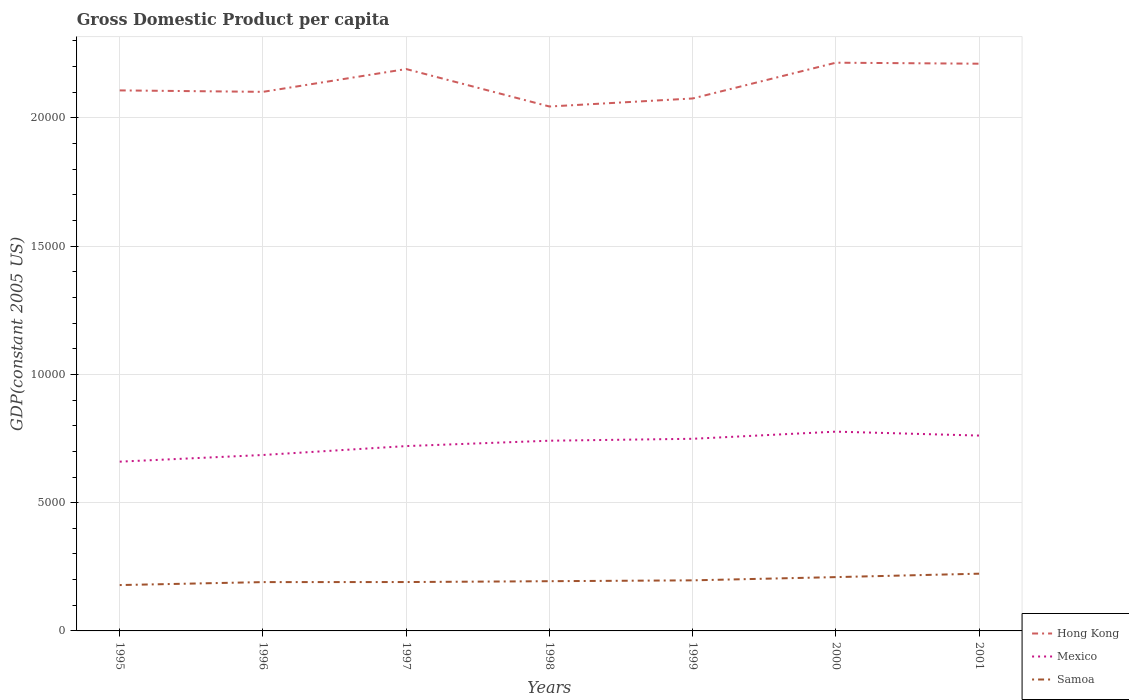Does the line corresponding to Hong Kong intersect with the line corresponding to Samoa?
Your response must be concise. No. Is the number of lines equal to the number of legend labels?
Provide a succinct answer. Yes. Across all years, what is the maximum GDP per capita in Samoa?
Keep it short and to the point. 1787.53. What is the total GDP per capita in Hong Kong in the graph?
Ensure brevity in your answer.  -208.59. What is the difference between the highest and the second highest GDP per capita in Samoa?
Keep it short and to the point. 443.83. What is the difference between the highest and the lowest GDP per capita in Mexico?
Keep it short and to the point. 4. What is the difference between two consecutive major ticks on the Y-axis?
Provide a succinct answer. 5000. Does the graph contain any zero values?
Provide a succinct answer. No. Where does the legend appear in the graph?
Your answer should be very brief. Bottom right. How many legend labels are there?
Ensure brevity in your answer.  3. What is the title of the graph?
Provide a succinct answer. Gross Domestic Product per capita. Does "Singapore" appear as one of the legend labels in the graph?
Offer a very short reply. No. What is the label or title of the X-axis?
Offer a terse response. Years. What is the label or title of the Y-axis?
Ensure brevity in your answer.  GDP(constant 2005 US). What is the GDP(constant 2005 US) of Hong Kong in 1995?
Give a very brief answer. 2.11e+04. What is the GDP(constant 2005 US) in Mexico in 1995?
Give a very brief answer. 6598.73. What is the GDP(constant 2005 US) in Samoa in 1995?
Offer a very short reply. 1787.53. What is the GDP(constant 2005 US) in Hong Kong in 1996?
Provide a short and direct response. 2.10e+04. What is the GDP(constant 2005 US) of Mexico in 1996?
Your answer should be compact. 6858.92. What is the GDP(constant 2005 US) in Samoa in 1996?
Your response must be concise. 1903.36. What is the GDP(constant 2005 US) of Hong Kong in 1997?
Ensure brevity in your answer.  2.19e+04. What is the GDP(constant 2005 US) of Mexico in 1997?
Ensure brevity in your answer.  7205.84. What is the GDP(constant 2005 US) in Samoa in 1997?
Make the answer very short. 1905.42. What is the GDP(constant 2005 US) of Hong Kong in 1998?
Offer a very short reply. 2.04e+04. What is the GDP(constant 2005 US) in Mexico in 1998?
Keep it short and to the point. 7415.42. What is the GDP(constant 2005 US) of Samoa in 1998?
Make the answer very short. 1938.37. What is the GDP(constant 2005 US) in Hong Kong in 1999?
Offer a terse response. 2.08e+04. What is the GDP(constant 2005 US) of Mexico in 1999?
Offer a very short reply. 7490.33. What is the GDP(constant 2005 US) of Samoa in 1999?
Provide a short and direct response. 1971.86. What is the GDP(constant 2005 US) in Hong Kong in 2000?
Your response must be concise. 2.22e+04. What is the GDP(constant 2005 US) in Mexico in 2000?
Your response must be concise. 7768.75. What is the GDP(constant 2005 US) of Samoa in 2000?
Offer a terse response. 2097.95. What is the GDP(constant 2005 US) of Hong Kong in 2001?
Ensure brevity in your answer.  2.21e+04. What is the GDP(constant 2005 US) in Mexico in 2001?
Provide a succinct answer. 7615.71. What is the GDP(constant 2005 US) of Samoa in 2001?
Your answer should be very brief. 2231.36. Across all years, what is the maximum GDP(constant 2005 US) in Hong Kong?
Provide a short and direct response. 2.22e+04. Across all years, what is the maximum GDP(constant 2005 US) in Mexico?
Give a very brief answer. 7768.75. Across all years, what is the maximum GDP(constant 2005 US) in Samoa?
Offer a terse response. 2231.36. Across all years, what is the minimum GDP(constant 2005 US) in Hong Kong?
Ensure brevity in your answer.  2.04e+04. Across all years, what is the minimum GDP(constant 2005 US) in Mexico?
Provide a short and direct response. 6598.73. Across all years, what is the minimum GDP(constant 2005 US) in Samoa?
Provide a succinct answer. 1787.53. What is the total GDP(constant 2005 US) of Hong Kong in the graph?
Give a very brief answer. 1.49e+05. What is the total GDP(constant 2005 US) in Mexico in the graph?
Offer a very short reply. 5.10e+04. What is the total GDP(constant 2005 US) in Samoa in the graph?
Your answer should be very brief. 1.38e+04. What is the difference between the GDP(constant 2005 US) of Hong Kong in 1995 and that in 1996?
Provide a short and direct response. 56.46. What is the difference between the GDP(constant 2005 US) in Mexico in 1995 and that in 1996?
Make the answer very short. -260.2. What is the difference between the GDP(constant 2005 US) in Samoa in 1995 and that in 1996?
Offer a terse response. -115.82. What is the difference between the GDP(constant 2005 US) of Hong Kong in 1995 and that in 1997?
Your answer should be compact. -832.15. What is the difference between the GDP(constant 2005 US) in Mexico in 1995 and that in 1997?
Offer a terse response. -607.11. What is the difference between the GDP(constant 2005 US) of Samoa in 1995 and that in 1997?
Make the answer very short. -117.89. What is the difference between the GDP(constant 2005 US) of Hong Kong in 1995 and that in 1998?
Give a very brief answer. 627.79. What is the difference between the GDP(constant 2005 US) in Mexico in 1995 and that in 1998?
Keep it short and to the point. -816.69. What is the difference between the GDP(constant 2005 US) of Samoa in 1995 and that in 1998?
Your answer should be compact. -150.84. What is the difference between the GDP(constant 2005 US) of Hong Kong in 1995 and that in 1999?
Provide a short and direct response. 314.53. What is the difference between the GDP(constant 2005 US) in Mexico in 1995 and that in 1999?
Provide a short and direct response. -891.6. What is the difference between the GDP(constant 2005 US) in Samoa in 1995 and that in 1999?
Your response must be concise. -184.32. What is the difference between the GDP(constant 2005 US) in Hong Kong in 1995 and that in 2000?
Give a very brief answer. -1080.07. What is the difference between the GDP(constant 2005 US) of Mexico in 1995 and that in 2000?
Keep it short and to the point. -1170.03. What is the difference between the GDP(constant 2005 US) of Samoa in 1995 and that in 2000?
Offer a very short reply. -310.41. What is the difference between the GDP(constant 2005 US) of Hong Kong in 1995 and that in 2001?
Your answer should be very brief. -1040.74. What is the difference between the GDP(constant 2005 US) in Mexico in 1995 and that in 2001?
Offer a very short reply. -1016.99. What is the difference between the GDP(constant 2005 US) in Samoa in 1995 and that in 2001?
Ensure brevity in your answer.  -443.83. What is the difference between the GDP(constant 2005 US) of Hong Kong in 1996 and that in 1997?
Keep it short and to the point. -888.61. What is the difference between the GDP(constant 2005 US) in Mexico in 1996 and that in 1997?
Offer a very short reply. -346.91. What is the difference between the GDP(constant 2005 US) in Samoa in 1996 and that in 1997?
Offer a terse response. -2.07. What is the difference between the GDP(constant 2005 US) in Hong Kong in 1996 and that in 1998?
Provide a succinct answer. 571.33. What is the difference between the GDP(constant 2005 US) in Mexico in 1996 and that in 1998?
Your response must be concise. -556.5. What is the difference between the GDP(constant 2005 US) in Samoa in 1996 and that in 1998?
Offer a very short reply. -35.02. What is the difference between the GDP(constant 2005 US) in Hong Kong in 1996 and that in 1999?
Give a very brief answer. 258.07. What is the difference between the GDP(constant 2005 US) in Mexico in 1996 and that in 1999?
Provide a short and direct response. -631.4. What is the difference between the GDP(constant 2005 US) in Samoa in 1996 and that in 1999?
Provide a succinct answer. -68.5. What is the difference between the GDP(constant 2005 US) in Hong Kong in 1996 and that in 2000?
Provide a short and direct response. -1136.54. What is the difference between the GDP(constant 2005 US) in Mexico in 1996 and that in 2000?
Make the answer very short. -909.83. What is the difference between the GDP(constant 2005 US) in Samoa in 1996 and that in 2000?
Keep it short and to the point. -194.59. What is the difference between the GDP(constant 2005 US) of Hong Kong in 1996 and that in 2001?
Ensure brevity in your answer.  -1097.2. What is the difference between the GDP(constant 2005 US) in Mexico in 1996 and that in 2001?
Your answer should be compact. -756.79. What is the difference between the GDP(constant 2005 US) of Samoa in 1996 and that in 2001?
Give a very brief answer. -328.01. What is the difference between the GDP(constant 2005 US) in Hong Kong in 1997 and that in 1998?
Your answer should be very brief. 1459.94. What is the difference between the GDP(constant 2005 US) of Mexico in 1997 and that in 1998?
Your response must be concise. -209.58. What is the difference between the GDP(constant 2005 US) of Samoa in 1997 and that in 1998?
Make the answer very short. -32.95. What is the difference between the GDP(constant 2005 US) of Hong Kong in 1997 and that in 1999?
Your answer should be compact. 1146.68. What is the difference between the GDP(constant 2005 US) in Mexico in 1997 and that in 1999?
Give a very brief answer. -284.49. What is the difference between the GDP(constant 2005 US) in Samoa in 1997 and that in 1999?
Make the answer very short. -66.43. What is the difference between the GDP(constant 2005 US) in Hong Kong in 1997 and that in 2000?
Make the answer very short. -247.93. What is the difference between the GDP(constant 2005 US) in Mexico in 1997 and that in 2000?
Your answer should be very brief. -562.92. What is the difference between the GDP(constant 2005 US) in Samoa in 1997 and that in 2000?
Offer a very short reply. -192.53. What is the difference between the GDP(constant 2005 US) in Hong Kong in 1997 and that in 2001?
Your response must be concise. -208.59. What is the difference between the GDP(constant 2005 US) in Mexico in 1997 and that in 2001?
Your answer should be very brief. -409.88. What is the difference between the GDP(constant 2005 US) in Samoa in 1997 and that in 2001?
Make the answer very short. -325.94. What is the difference between the GDP(constant 2005 US) in Hong Kong in 1998 and that in 1999?
Your response must be concise. -313.26. What is the difference between the GDP(constant 2005 US) of Mexico in 1998 and that in 1999?
Provide a short and direct response. -74.91. What is the difference between the GDP(constant 2005 US) of Samoa in 1998 and that in 1999?
Provide a succinct answer. -33.48. What is the difference between the GDP(constant 2005 US) in Hong Kong in 1998 and that in 2000?
Ensure brevity in your answer.  -1707.87. What is the difference between the GDP(constant 2005 US) of Mexico in 1998 and that in 2000?
Offer a terse response. -353.33. What is the difference between the GDP(constant 2005 US) of Samoa in 1998 and that in 2000?
Ensure brevity in your answer.  -159.58. What is the difference between the GDP(constant 2005 US) in Hong Kong in 1998 and that in 2001?
Give a very brief answer. -1668.53. What is the difference between the GDP(constant 2005 US) in Mexico in 1998 and that in 2001?
Your answer should be compact. -200.29. What is the difference between the GDP(constant 2005 US) in Samoa in 1998 and that in 2001?
Ensure brevity in your answer.  -292.99. What is the difference between the GDP(constant 2005 US) in Hong Kong in 1999 and that in 2000?
Offer a very short reply. -1394.61. What is the difference between the GDP(constant 2005 US) of Mexico in 1999 and that in 2000?
Provide a short and direct response. -278.43. What is the difference between the GDP(constant 2005 US) of Samoa in 1999 and that in 2000?
Offer a very short reply. -126.09. What is the difference between the GDP(constant 2005 US) of Hong Kong in 1999 and that in 2001?
Provide a succinct answer. -1355.27. What is the difference between the GDP(constant 2005 US) of Mexico in 1999 and that in 2001?
Offer a very short reply. -125.39. What is the difference between the GDP(constant 2005 US) in Samoa in 1999 and that in 2001?
Give a very brief answer. -259.51. What is the difference between the GDP(constant 2005 US) of Hong Kong in 2000 and that in 2001?
Your response must be concise. 39.34. What is the difference between the GDP(constant 2005 US) of Mexico in 2000 and that in 2001?
Your answer should be very brief. 153.04. What is the difference between the GDP(constant 2005 US) in Samoa in 2000 and that in 2001?
Provide a succinct answer. -133.41. What is the difference between the GDP(constant 2005 US) in Hong Kong in 1995 and the GDP(constant 2005 US) in Mexico in 1996?
Offer a very short reply. 1.42e+04. What is the difference between the GDP(constant 2005 US) in Hong Kong in 1995 and the GDP(constant 2005 US) in Samoa in 1996?
Make the answer very short. 1.92e+04. What is the difference between the GDP(constant 2005 US) of Mexico in 1995 and the GDP(constant 2005 US) of Samoa in 1996?
Ensure brevity in your answer.  4695.37. What is the difference between the GDP(constant 2005 US) in Hong Kong in 1995 and the GDP(constant 2005 US) in Mexico in 1997?
Your answer should be compact. 1.39e+04. What is the difference between the GDP(constant 2005 US) of Hong Kong in 1995 and the GDP(constant 2005 US) of Samoa in 1997?
Provide a succinct answer. 1.92e+04. What is the difference between the GDP(constant 2005 US) in Mexico in 1995 and the GDP(constant 2005 US) in Samoa in 1997?
Offer a very short reply. 4693.3. What is the difference between the GDP(constant 2005 US) of Hong Kong in 1995 and the GDP(constant 2005 US) of Mexico in 1998?
Ensure brevity in your answer.  1.37e+04. What is the difference between the GDP(constant 2005 US) of Hong Kong in 1995 and the GDP(constant 2005 US) of Samoa in 1998?
Give a very brief answer. 1.91e+04. What is the difference between the GDP(constant 2005 US) of Mexico in 1995 and the GDP(constant 2005 US) of Samoa in 1998?
Offer a terse response. 4660.35. What is the difference between the GDP(constant 2005 US) in Hong Kong in 1995 and the GDP(constant 2005 US) in Mexico in 1999?
Your answer should be very brief. 1.36e+04. What is the difference between the GDP(constant 2005 US) of Hong Kong in 1995 and the GDP(constant 2005 US) of Samoa in 1999?
Provide a succinct answer. 1.91e+04. What is the difference between the GDP(constant 2005 US) of Mexico in 1995 and the GDP(constant 2005 US) of Samoa in 1999?
Your response must be concise. 4626.87. What is the difference between the GDP(constant 2005 US) of Hong Kong in 1995 and the GDP(constant 2005 US) of Mexico in 2000?
Your answer should be compact. 1.33e+04. What is the difference between the GDP(constant 2005 US) in Hong Kong in 1995 and the GDP(constant 2005 US) in Samoa in 2000?
Offer a terse response. 1.90e+04. What is the difference between the GDP(constant 2005 US) of Mexico in 1995 and the GDP(constant 2005 US) of Samoa in 2000?
Your response must be concise. 4500.78. What is the difference between the GDP(constant 2005 US) in Hong Kong in 1995 and the GDP(constant 2005 US) in Mexico in 2001?
Offer a very short reply. 1.35e+04. What is the difference between the GDP(constant 2005 US) in Hong Kong in 1995 and the GDP(constant 2005 US) in Samoa in 2001?
Provide a succinct answer. 1.88e+04. What is the difference between the GDP(constant 2005 US) in Mexico in 1995 and the GDP(constant 2005 US) in Samoa in 2001?
Your response must be concise. 4367.36. What is the difference between the GDP(constant 2005 US) of Hong Kong in 1996 and the GDP(constant 2005 US) of Mexico in 1997?
Offer a terse response. 1.38e+04. What is the difference between the GDP(constant 2005 US) of Hong Kong in 1996 and the GDP(constant 2005 US) of Samoa in 1997?
Give a very brief answer. 1.91e+04. What is the difference between the GDP(constant 2005 US) in Mexico in 1996 and the GDP(constant 2005 US) in Samoa in 1997?
Ensure brevity in your answer.  4953.5. What is the difference between the GDP(constant 2005 US) of Hong Kong in 1996 and the GDP(constant 2005 US) of Mexico in 1998?
Offer a terse response. 1.36e+04. What is the difference between the GDP(constant 2005 US) in Hong Kong in 1996 and the GDP(constant 2005 US) in Samoa in 1998?
Offer a terse response. 1.91e+04. What is the difference between the GDP(constant 2005 US) in Mexico in 1996 and the GDP(constant 2005 US) in Samoa in 1998?
Your answer should be very brief. 4920.55. What is the difference between the GDP(constant 2005 US) in Hong Kong in 1996 and the GDP(constant 2005 US) in Mexico in 1999?
Provide a short and direct response. 1.35e+04. What is the difference between the GDP(constant 2005 US) in Hong Kong in 1996 and the GDP(constant 2005 US) in Samoa in 1999?
Ensure brevity in your answer.  1.90e+04. What is the difference between the GDP(constant 2005 US) of Mexico in 1996 and the GDP(constant 2005 US) of Samoa in 1999?
Provide a succinct answer. 4887.07. What is the difference between the GDP(constant 2005 US) of Hong Kong in 1996 and the GDP(constant 2005 US) of Mexico in 2000?
Your answer should be very brief. 1.32e+04. What is the difference between the GDP(constant 2005 US) in Hong Kong in 1996 and the GDP(constant 2005 US) in Samoa in 2000?
Give a very brief answer. 1.89e+04. What is the difference between the GDP(constant 2005 US) of Mexico in 1996 and the GDP(constant 2005 US) of Samoa in 2000?
Provide a succinct answer. 4760.97. What is the difference between the GDP(constant 2005 US) in Hong Kong in 1996 and the GDP(constant 2005 US) in Mexico in 2001?
Provide a succinct answer. 1.34e+04. What is the difference between the GDP(constant 2005 US) in Hong Kong in 1996 and the GDP(constant 2005 US) in Samoa in 2001?
Your answer should be compact. 1.88e+04. What is the difference between the GDP(constant 2005 US) of Mexico in 1996 and the GDP(constant 2005 US) of Samoa in 2001?
Offer a terse response. 4627.56. What is the difference between the GDP(constant 2005 US) of Hong Kong in 1997 and the GDP(constant 2005 US) of Mexico in 1998?
Offer a terse response. 1.45e+04. What is the difference between the GDP(constant 2005 US) of Hong Kong in 1997 and the GDP(constant 2005 US) of Samoa in 1998?
Your answer should be very brief. 2.00e+04. What is the difference between the GDP(constant 2005 US) in Mexico in 1997 and the GDP(constant 2005 US) in Samoa in 1998?
Provide a short and direct response. 5267.46. What is the difference between the GDP(constant 2005 US) in Hong Kong in 1997 and the GDP(constant 2005 US) in Mexico in 1999?
Ensure brevity in your answer.  1.44e+04. What is the difference between the GDP(constant 2005 US) of Hong Kong in 1997 and the GDP(constant 2005 US) of Samoa in 1999?
Offer a very short reply. 1.99e+04. What is the difference between the GDP(constant 2005 US) in Mexico in 1997 and the GDP(constant 2005 US) in Samoa in 1999?
Provide a succinct answer. 5233.98. What is the difference between the GDP(constant 2005 US) of Hong Kong in 1997 and the GDP(constant 2005 US) of Mexico in 2000?
Offer a terse response. 1.41e+04. What is the difference between the GDP(constant 2005 US) of Hong Kong in 1997 and the GDP(constant 2005 US) of Samoa in 2000?
Provide a short and direct response. 1.98e+04. What is the difference between the GDP(constant 2005 US) in Mexico in 1997 and the GDP(constant 2005 US) in Samoa in 2000?
Provide a short and direct response. 5107.89. What is the difference between the GDP(constant 2005 US) in Hong Kong in 1997 and the GDP(constant 2005 US) in Mexico in 2001?
Offer a very short reply. 1.43e+04. What is the difference between the GDP(constant 2005 US) of Hong Kong in 1997 and the GDP(constant 2005 US) of Samoa in 2001?
Keep it short and to the point. 1.97e+04. What is the difference between the GDP(constant 2005 US) in Mexico in 1997 and the GDP(constant 2005 US) in Samoa in 2001?
Your answer should be very brief. 4974.47. What is the difference between the GDP(constant 2005 US) in Hong Kong in 1998 and the GDP(constant 2005 US) in Mexico in 1999?
Provide a short and direct response. 1.30e+04. What is the difference between the GDP(constant 2005 US) of Hong Kong in 1998 and the GDP(constant 2005 US) of Samoa in 1999?
Ensure brevity in your answer.  1.85e+04. What is the difference between the GDP(constant 2005 US) of Mexico in 1998 and the GDP(constant 2005 US) of Samoa in 1999?
Your response must be concise. 5443.56. What is the difference between the GDP(constant 2005 US) in Hong Kong in 1998 and the GDP(constant 2005 US) in Mexico in 2000?
Provide a short and direct response. 1.27e+04. What is the difference between the GDP(constant 2005 US) in Hong Kong in 1998 and the GDP(constant 2005 US) in Samoa in 2000?
Give a very brief answer. 1.83e+04. What is the difference between the GDP(constant 2005 US) in Mexico in 1998 and the GDP(constant 2005 US) in Samoa in 2000?
Your answer should be compact. 5317.47. What is the difference between the GDP(constant 2005 US) of Hong Kong in 1998 and the GDP(constant 2005 US) of Mexico in 2001?
Your answer should be compact. 1.28e+04. What is the difference between the GDP(constant 2005 US) of Hong Kong in 1998 and the GDP(constant 2005 US) of Samoa in 2001?
Your response must be concise. 1.82e+04. What is the difference between the GDP(constant 2005 US) in Mexico in 1998 and the GDP(constant 2005 US) in Samoa in 2001?
Provide a succinct answer. 5184.06. What is the difference between the GDP(constant 2005 US) of Hong Kong in 1999 and the GDP(constant 2005 US) of Mexico in 2000?
Your response must be concise. 1.30e+04. What is the difference between the GDP(constant 2005 US) of Hong Kong in 1999 and the GDP(constant 2005 US) of Samoa in 2000?
Give a very brief answer. 1.87e+04. What is the difference between the GDP(constant 2005 US) in Mexico in 1999 and the GDP(constant 2005 US) in Samoa in 2000?
Keep it short and to the point. 5392.38. What is the difference between the GDP(constant 2005 US) of Hong Kong in 1999 and the GDP(constant 2005 US) of Mexico in 2001?
Your answer should be compact. 1.31e+04. What is the difference between the GDP(constant 2005 US) in Hong Kong in 1999 and the GDP(constant 2005 US) in Samoa in 2001?
Make the answer very short. 1.85e+04. What is the difference between the GDP(constant 2005 US) in Mexico in 1999 and the GDP(constant 2005 US) in Samoa in 2001?
Provide a succinct answer. 5258.96. What is the difference between the GDP(constant 2005 US) of Hong Kong in 2000 and the GDP(constant 2005 US) of Mexico in 2001?
Give a very brief answer. 1.45e+04. What is the difference between the GDP(constant 2005 US) of Hong Kong in 2000 and the GDP(constant 2005 US) of Samoa in 2001?
Make the answer very short. 1.99e+04. What is the difference between the GDP(constant 2005 US) in Mexico in 2000 and the GDP(constant 2005 US) in Samoa in 2001?
Ensure brevity in your answer.  5537.39. What is the average GDP(constant 2005 US) in Hong Kong per year?
Provide a succinct answer. 2.14e+04. What is the average GDP(constant 2005 US) of Mexico per year?
Offer a very short reply. 7279.1. What is the average GDP(constant 2005 US) in Samoa per year?
Ensure brevity in your answer.  1976.55. In the year 1995, what is the difference between the GDP(constant 2005 US) in Hong Kong and GDP(constant 2005 US) in Mexico?
Your answer should be very brief. 1.45e+04. In the year 1995, what is the difference between the GDP(constant 2005 US) in Hong Kong and GDP(constant 2005 US) in Samoa?
Make the answer very short. 1.93e+04. In the year 1995, what is the difference between the GDP(constant 2005 US) in Mexico and GDP(constant 2005 US) in Samoa?
Keep it short and to the point. 4811.19. In the year 1996, what is the difference between the GDP(constant 2005 US) of Hong Kong and GDP(constant 2005 US) of Mexico?
Make the answer very short. 1.42e+04. In the year 1996, what is the difference between the GDP(constant 2005 US) in Hong Kong and GDP(constant 2005 US) in Samoa?
Provide a short and direct response. 1.91e+04. In the year 1996, what is the difference between the GDP(constant 2005 US) in Mexico and GDP(constant 2005 US) in Samoa?
Your response must be concise. 4955.57. In the year 1997, what is the difference between the GDP(constant 2005 US) in Hong Kong and GDP(constant 2005 US) in Mexico?
Give a very brief answer. 1.47e+04. In the year 1997, what is the difference between the GDP(constant 2005 US) of Hong Kong and GDP(constant 2005 US) of Samoa?
Your answer should be very brief. 2.00e+04. In the year 1997, what is the difference between the GDP(constant 2005 US) in Mexico and GDP(constant 2005 US) in Samoa?
Give a very brief answer. 5300.41. In the year 1998, what is the difference between the GDP(constant 2005 US) of Hong Kong and GDP(constant 2005 US) of Mexico?
Ensure brevity in your answer.  1.30e+04. In the year 1998, what is the difference between the GDP(constant 2005 US) of Hong Kong and GDP(constant 2005 US) of Samoa?
Your answer should be very brief. 1.85e+04. In the year 1998, what is the difference between the GDP(constant 2005 US) of Mexico and GDP(constant 2005 US) of Samoa?
Make the answer very short. 5477.05. In the year 1999, what is the difference between the GDP(constant 2005 US) in Hong Kong and GDP(constant 2005 US) in Mexico?
Your answer should be very brief. 1.33e+04. In the year 1999, what is the difference between the GDP(constant 2005 US) in Hong Kong and GDP(constant 2005 US) in Samoa?
Ensure brevity in your answer.  1.88e+04. In the year 1999, what is the difference between the GDP(constant 2005 US) of Mexico and GDP(constant 2005 US) of Samoa?
Ensure brevity in your answer.  5518.47. In the year 2000, what is the difference between the GDP(constant 2005 US) of Hong Kong and GDP(constant 2005 US) of Mexico?
Offer a very short reply. 1.44e+04. In the year 2000, what is the difference between the GDP(constant 2005 US) in Hong Kong and GDP(constant 2005 US) in Samoa?
Provide a short and direct response. 2.01e+04. In the year 2000, what is the difference between the GDP(constant 2005 US) of Mexico and GDP(constant 2005 US) of Samoa?
Keep it short and to the point. 5670.8. In the year 2001, what is the difference between the GDP(constant 2005 US) of Hong Kong and GDP(constant 2005 US) of Mexico?
Your response must be concise. 1.45e+04. In the year 2001, what is the difference between the GDP(constant 2005 US) in Hong Kong and GDP(constant 2005 US) in Samoa?
Offer a terse response. 1.99e+04. In the year 2001, what is the difference between the GDP(constant 2005 US) of Mexico and GDP(constant 2005 US) of Samoa?
Offer a very short reply. 5384.35. What is the ratio of the GDP(constant 2005 US) of Mexico in 1995 to that in 1996?
Give a very brief answer. 0.96. What is the ratio of the GDP(constant 2005 US) of Samoa in 1995 to that in 1996?
Offer a terse response. 0.94. What is the ratio of the GDP(constant 2005 US) in Mexico in 1995 to that in 1997?
Ensure brevity in your answer.  0.92. What is the ratio of the GDP(constant 2005 US) in Samoa in 1995 to that in 1997?
Provide a succinct answer. 0.94. What is the ratio of the GDP(constant 2005 US) in Hong Kong in 1995 to that in 1998?
Offer a very short reply. 1.03. What is the ratio of the GDP(constant 2005 US) in Mexico in 1995 to that in 1998?
Your answer should be compact. 0.89. What is the ratio of the GDP(constant 2005 US) of Samoa in 1995 to that in 1998?
Provide a succinct answer. 0.92. What is the ratio of the GDP(constant 2005 US) in Hong Kong in 1995 to that in 1999?
Provide a succinct answer. 1.02. What is the ratio of the GDP(constant 2005 US) of Mexico in 1995 to that in 1999?
Offer a very short reply. 0.88. What is the ratio of the GDP(constant 2005 US) in Samoa in 1995 to that in 1999?
Provide a succinct answer. 0.91. What is the ratio of the GDP(constant 2005 US) of Hong Kong in 1995 to that in 2000?
Your response must be concise. 0.95. What is the ratio of the GDP(constant 2005 US) in Mexico in 1995 to that in 2000?
Provide a short and direct response. 0.85. What is the ratio of the GDP(constant 2005 US) in Samoa in 1995 to that in 2000?
Ensure brevity in your answer.  0.85. What is the ratio of the GDP(constant 2005 US) of Hong Kong in 1995 to that in 2001?
Keep it short and to the point. 0.95. What is the ratio of the GDP(constant 2005 US) in Mexico in 1995 to that in 2001?
Give a very brief answer. 0.87. What is the ratio of the GDP(constant 2005 US) of Samoa in 1995 to that in 2001?
Offer a terse response. 0.8. What is the ratio of the GDP(constant 2005 US) in Hong Kong in 1996 to that in 1997?
Make the answer very short. 0.96. What is the ratio of the GDP(constant 2005 US) of Mexico in 1996 to that in 1997?
Keep it short and to the point. 0.95. What is the ratio of the GDP(constant 2005 US) in Hong Kong in 1996 to that in 1998?
Provide a succinct answer. 1.03. What is the ratio of the GDP(constant 2005 US) of Mexico in 1996 to that in 1998?
Provide a succinct answer. 0.93. What is the ratio of the GDP(constant 2005 US) in Samoa in 1996 to that in 1998?
Your answer should be compact. 0.98. What is the ratio of the GDP(constant 2005 US) in Hong Kong in 1996 to that in 1999?
Your answer should be compact. 1.01. What is the ratio of the GDP(constant 2005 US) of Mexico in 1996 to that in 1999?
Your answer should be compact. 0.92. What is the ratio of the GDP(constant 2005 US) in Samoa in 1996 to that in 1999?
Your response must be concise. 0.97. What is the ratio of the GDP(constant 2005 US) of Hong Kong in 1996 to that in 2000?
Provide a succinct answer. 0.95. What is the ratio of the GDP(constant 2005 US) of Mexico in 1996 to that in 2000?
Provide a succinct answer. 0.88. What is the ratio of the GDP(constant 2005 US) in Samoa in 1996 to that in 2000?
Your response must be concise. 0.91. What is the ratio of the GDP(constant 2005 US) in Hong Kong in 1996 to that in 2001?
Your answer should be very brief. 0.95. What is the ratio of the GDP(constant 2005 US) of Mexico in 1996 to that in 2001?
Your answer should be compact. 0.9. What is the ratio of the GDP(constant 2005 US) of Samoa in 1996 to that in 2001?
Keep it short and to the point. 0.85. What is the ratio of the GDP(constant 2005 US) in Hong Kong in 1997 to that in 1998?
Ensure brevity in your answer.  1.07. What is the ratio of the GDP(constant 2005 US) of Mexico in 1997 to that in 1998?
Keep it short and to the point. 0.97. What is the ratio of the GDP(constant 2005 US) in Samoa in 1997 to that in 1998?
Provide a short and direct response. 0.98. What is the ratio of the GDP(constant 2005 US) in Hong Kong in 1997 to that in 1999?
Offer a very short reply. 1.06. What is the ratio of the GDP(constant 2005 US) of Mexico in 1997 to that in 1999?
Offer a very short reply. 0.96. What is the ratio of the GDP(constant 2005 US) of Samoa in 1997 to that in 1999?
Give a very brief answer. 0.97. What is the ratio of the GDP(constant 2005 US) in Hong Kong in 1997 to that in 2000?
Your answer should be very brief. 0.99. What is the ratio of the GDP(constant 2005 US) in Mexico in 1997 to that in 2000?
Ensure brevity in your answer.  0.93. What is the ratio of the GDP(constant 2005 US) of Samoa in 1997 to that in 2000?
Your response must be concise. 0.91. What is the ratio of the GDP(constant 2005 US) in Hong Kong in 1997 to that in 2001?
Offer a terse response. 0.99. What is the ratio of the GDP(constant 2005 US) of Mexico in 1997 to that in 2001?
Ensure brevity in your answer.  0.95. What is the ratio of the GDP(constant 2005 US) of Samoa in 1997 to that in 2001?
Provide a short and direct response. 0.85. What is the ratio of the GDP(constant 2005 US) in Hong Kong in 1998 to that in 1999?
Keep it short and to the point. 0.98. What is the ratio of the GDP(constant 2005 US) of Mexico in 1998 to that in 1999?
Make the answer very short. 0.99. What is the ratio of the GDP(constant 2005 US) in Hong Kong in 1998 to that in 2000?
Give a very brief answer. 0.92. What is the ratio of the GDP(constant 2005 US) of Mexico in 1998 to that in 2000?
Provide a short and direct response. 0.95. What is the ratio of the GDP(constant 2005 US) of Samoa in 1998 to that in 2000?
Your answer should be compact. 0.92. What is the ratio of the GDP(constant 2005 US) in Hong Kong in 1998 to that in 2001?
Your response must be concise. 0.92. What is the ratio of the GDP(constant 2005 US) in Mexico in 1998 to that in 2001?
Your answer should be very brief. 0.97. What is the ratio of the GDP(constant 2005 US) of Samoa in 1998 to that in 2001?
Your answer should be very brief. 0.87. What is the ratio of the GDP(constant 2005 US) of Hong Kong in 1999 to that in 2000?
Keep it short and to the point. 0.94. What is the ratio of the GDP(constant 2005 US) of Mexico in 1999 to that in 2000?
Your answer should be very brief. 0.96. What is the ratio of the GDP(constant 2005 US) in Samoa in 1999 to that in 2000?
Provide a succinct answer. 0.94. What is the ratio of the GDP(constant 2005 US) in Hong Kong in 1999 to that in 2001?
Provide a short and direct response. 0.94. What is the ratio of the GDP(constant 2005 US) of Mexico in 1999 to that in 2001?
Ensure brevity in your answer.  0.98. What is the ratio of the GDP(constant 2005 US) in Samoa in 1999 to that in 2001?
Offer a terse response. 0.88. What is the ratio of the GDP(constant 2005 US) in Hong Kong in 2000 to that in 2001?
Provide a succinct answer. 1. What is the ratio of the GDP(constant 2005 US) of Mexico in 2000 to that in 2001?
Offer a terse response. 1.02. What is the ratio of the GDP(constant 2005 US) of Samoa in 2000 to that in 2001?
Keep it short and to the point. 0.94. What is the difference between the highest and the second highest GDP(constant 2005 US) in Hong Kong?
Ensure brevity in your answer.  39.34. What is the difference between the highest and the second highest GDP(constant 2005 US) of Mexico?
Your answer should be very brief. 153.04. What is the difference between the highest and the second highest GDP(constant 2005 US) in Samoa?
Ensure brevity in your answer.  133.41. What is the difference between the highest and the lowest GDP(constant 2005 US) of Hong Kong?
Give a very brief answer. 1707.87. What is the difference between the highest and the lowest GDP(constant 2005 US) in Mexico?
Provide a succinct answer. 1170.03. What is the difference between the highest and the lowest GDP(constant 2005 US) in Samoa?
Your answer should be compact. 443.83. 